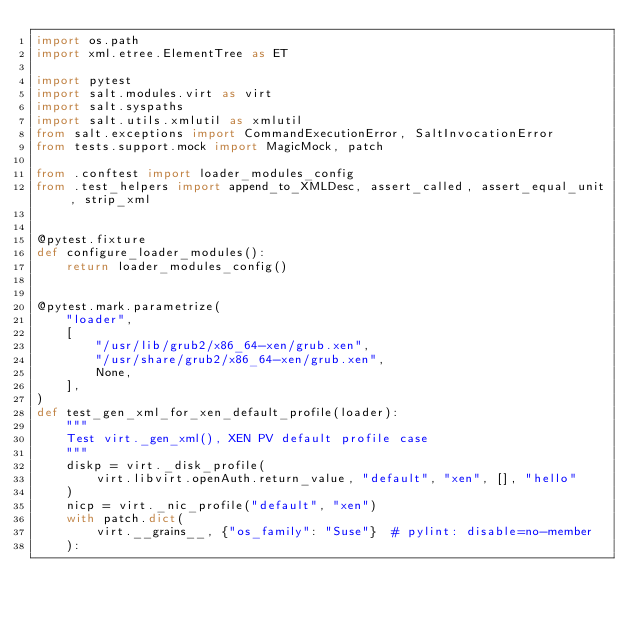<code> <loc_0><loc_0><loc_500><loc_500><_Python_>import os.path
import xml.etree.ElementTree as ET

import pytest
import salt.modules.virt as virt
import salt.syspaths
import salt.utils.xmlutil as xmlutil
from salt.exceptions import CommandExecutionError, SaltInvocationError
from tests.support.mock import MagicMock, patch

from .conftest import loader_modules_config
from .test_helpers import append_to_XMLDesc, assert_called, assert_equal_unit, strip_xml


@pytest.fixture
def configure_loader_modules():
    return loader_modules_config()


@pytest.mark.parametrize(
    "loader",
    [
        "/usr/lib/grub2/x86_64-xen/grub.xen",
        "/usr/share/grub2/x86_64-xen/grub.xen",
        None,
    ],
)
def test_gen_xml_for_xen_default_profile(loader):
    """
    Test virt._gen_xml(), XEN PV default profile case
    """
    diskp = virt._disk_profile(
        virt.libvirt.openAuth.return_value, "default", "xen", [], "hello"
    )
    nicp = virt._nic_profile("default", "xen")
    with patch.dict(
        virt.__grains__, {"os_family": "Suse"}  # pylint: disable=no-member
    ):</code> 